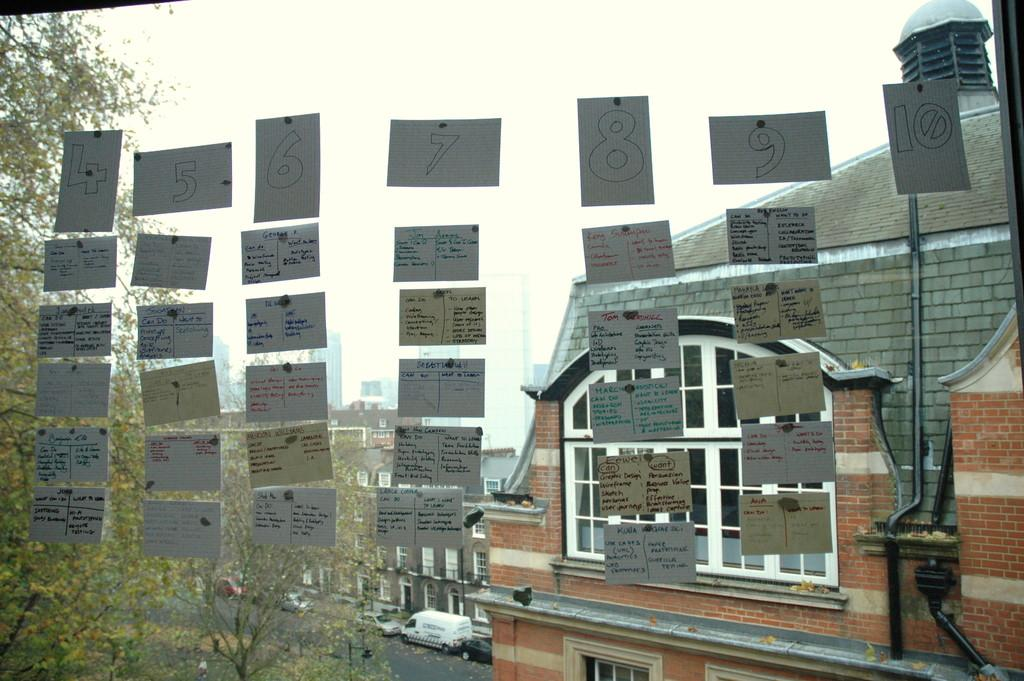What is on the glass in the image? There are paper notes on a glass in the image. What can be seen through the glass? Trees, vehicles on the road, buildings, and the sky can be seen through the glass. What type of surprise can be seen in the basin in the image? There is no basin or surprise present in the image. 